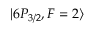<formula> <loc_0><loc_0><loc_500><loc_500>| 6 P _ { 3 / 2 } , F = 2 \rangle</formula> 